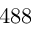<formula> <loc_0><loc_0><loc_500><loc_500>4 8 8</formula> 